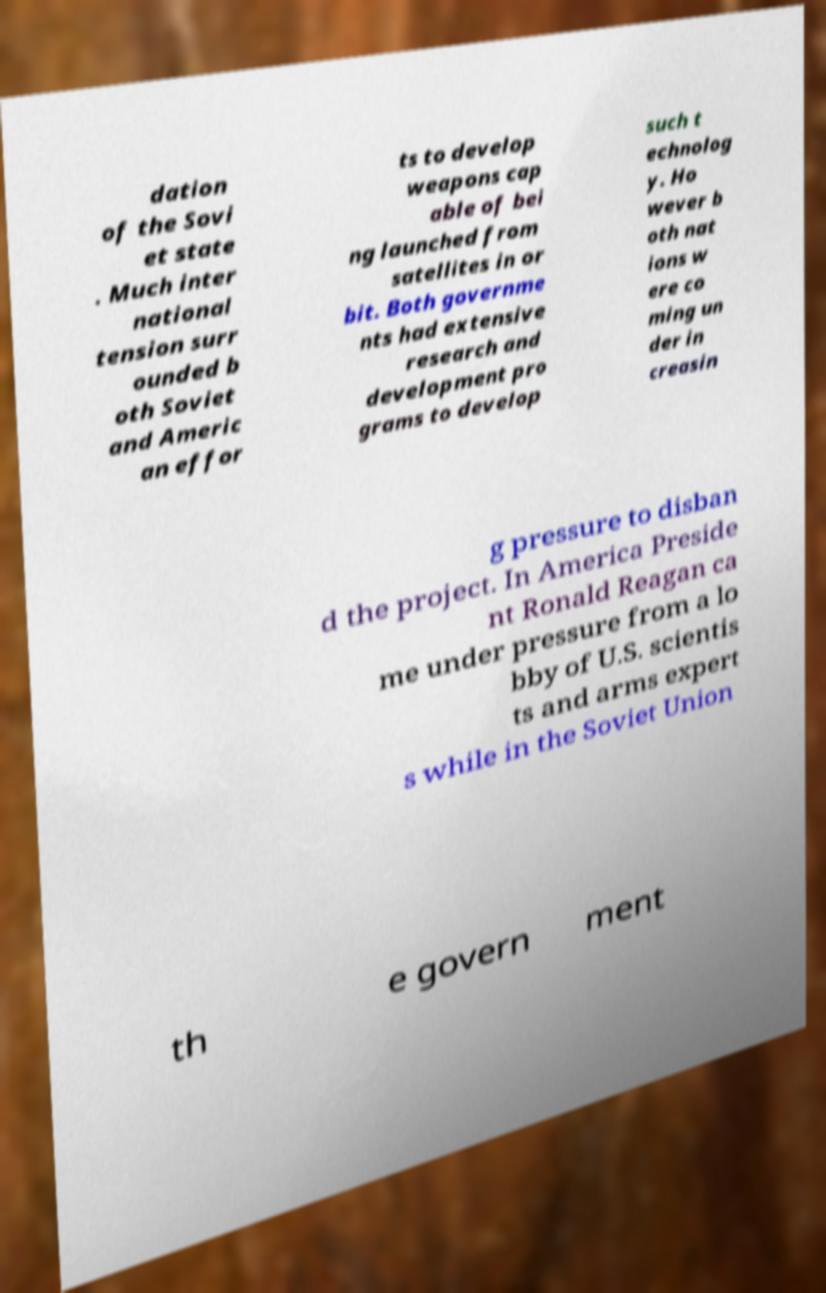What messages or text are displayed in this image? I need them in a readable, typed format. dation of the Sovi et state . Much inter national tension surr ounded b oth Soviet and Americ an effor ts to develop weapons cap able of bei ng launched from satellites in or bit. Both governme nts had extensive research and development pro grams to develop such t echnolog y. Ho wever b oth nat ions w ere co ming un der in creasin g pressure to disban d the project. In America Preside nt Ronald Reagan ca me under pressure from a lo bby of U.S. scientis ts and arms expert s while in the Soviet Union th e govern ment 